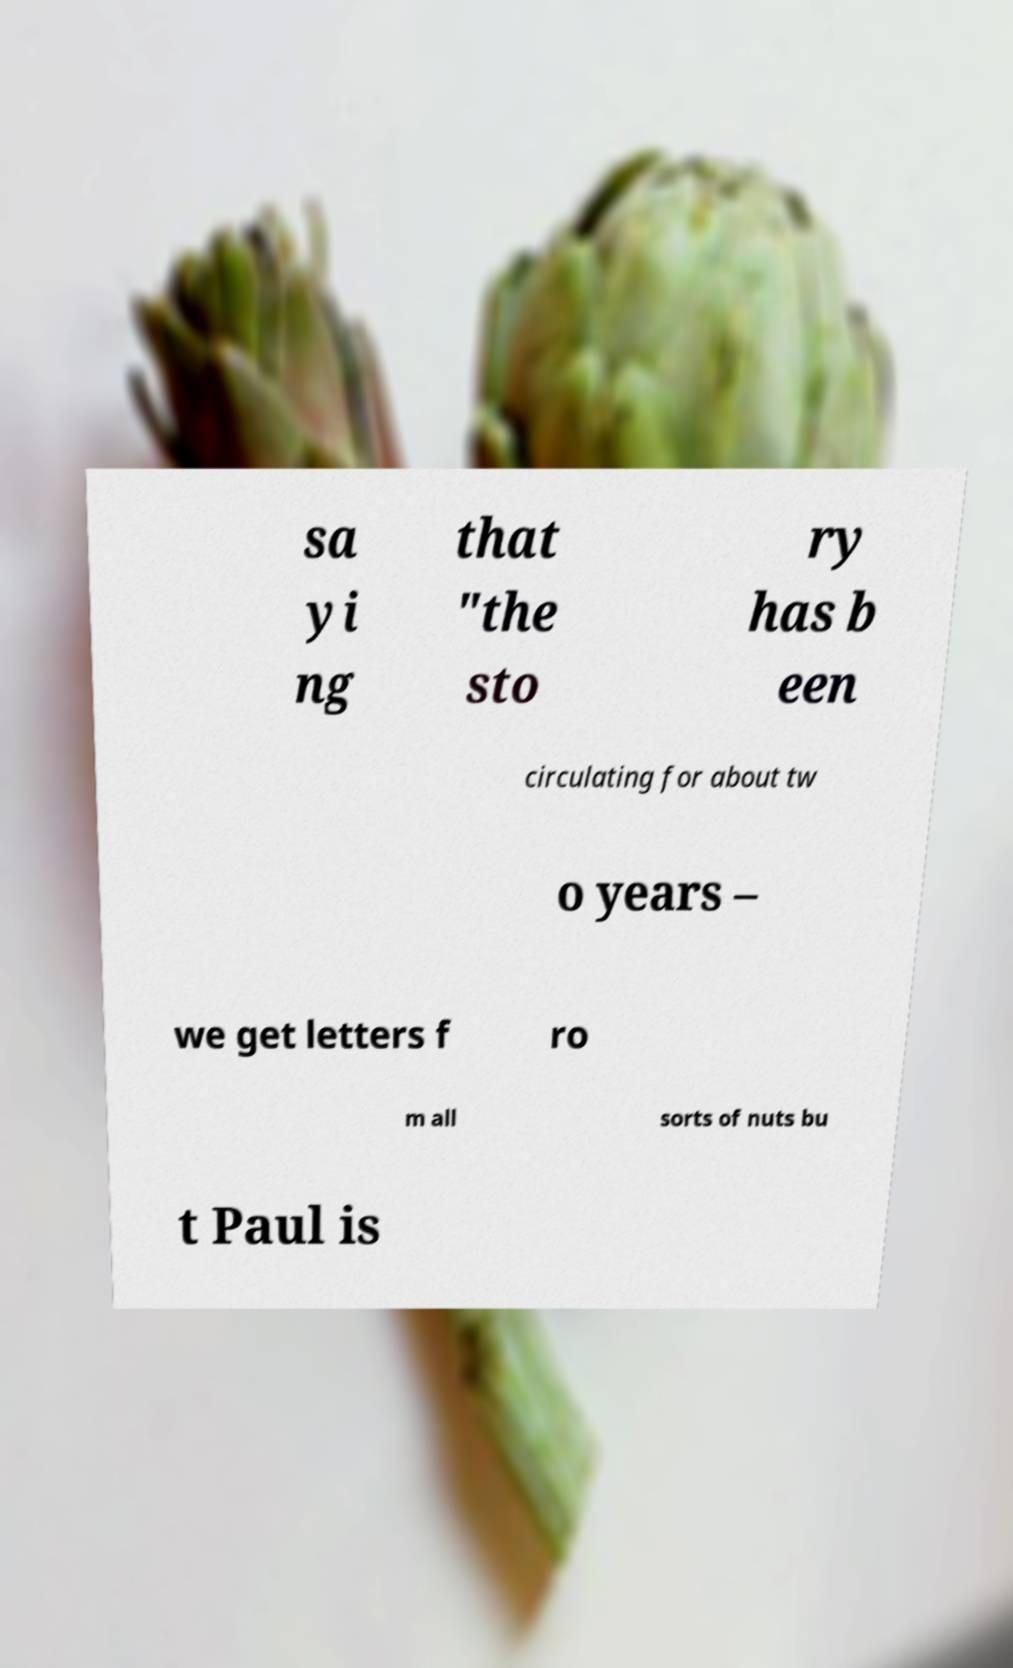Could you extract and type out the text from this image? sa yi ng that "the sto ry has b een circulating for about tw o years – we get letters f ro m all sorts of nuts bu t Paul is 